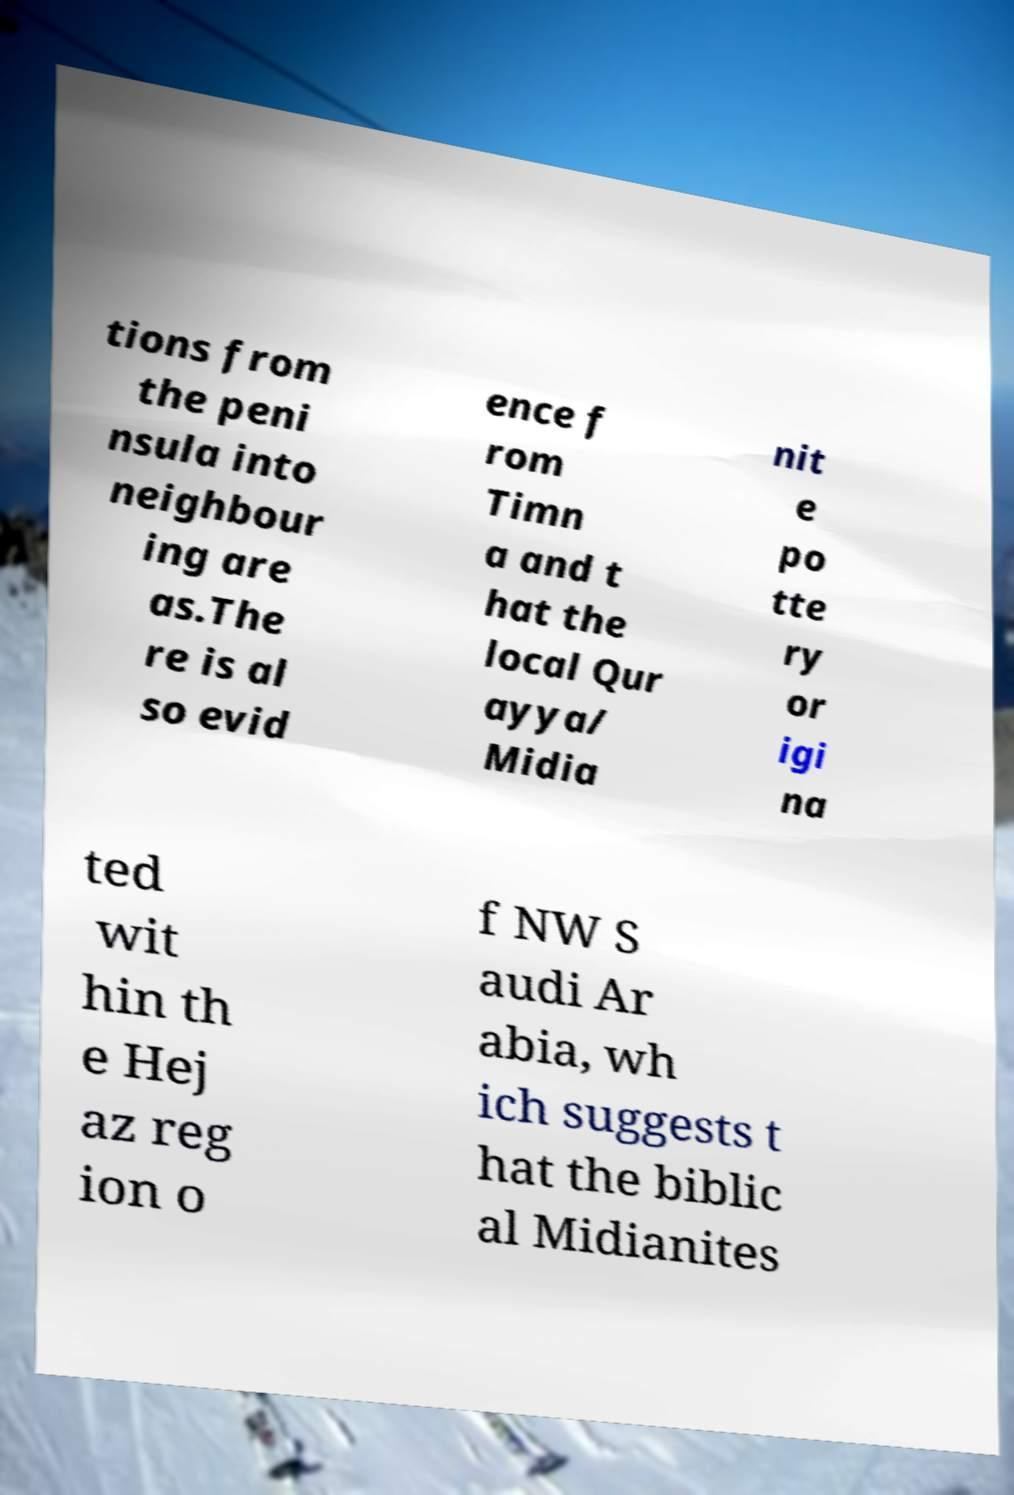For documentation purposes, I need the text within this image transcribed. Could you provide that? tions from the peni nsula into neighbour ing are as.The re is al so evid ence f rom Timn a and t hat the local Qur ayya/ Midia nit e po tte ry or igi na ted wit hin th e Hej az reg ion o f NW S audi Ar abia, wh ich suggests t hat the biblic al Midianites 